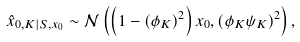Convert formula to latex. <formula><loc_0><loc_0><loc_500><loc_500>\hat { x } _ { 0 , K | S , x _ { 0 } } \sim \mathcal { N } \left ( \left ( 1 - ( \phi _ { K } ) ^ { 2 } \right ) x _ { 0 } , \left ( \phi _ { K } \psi _ { K } \right ) ^ { 2 } \right ) ,</formula> 